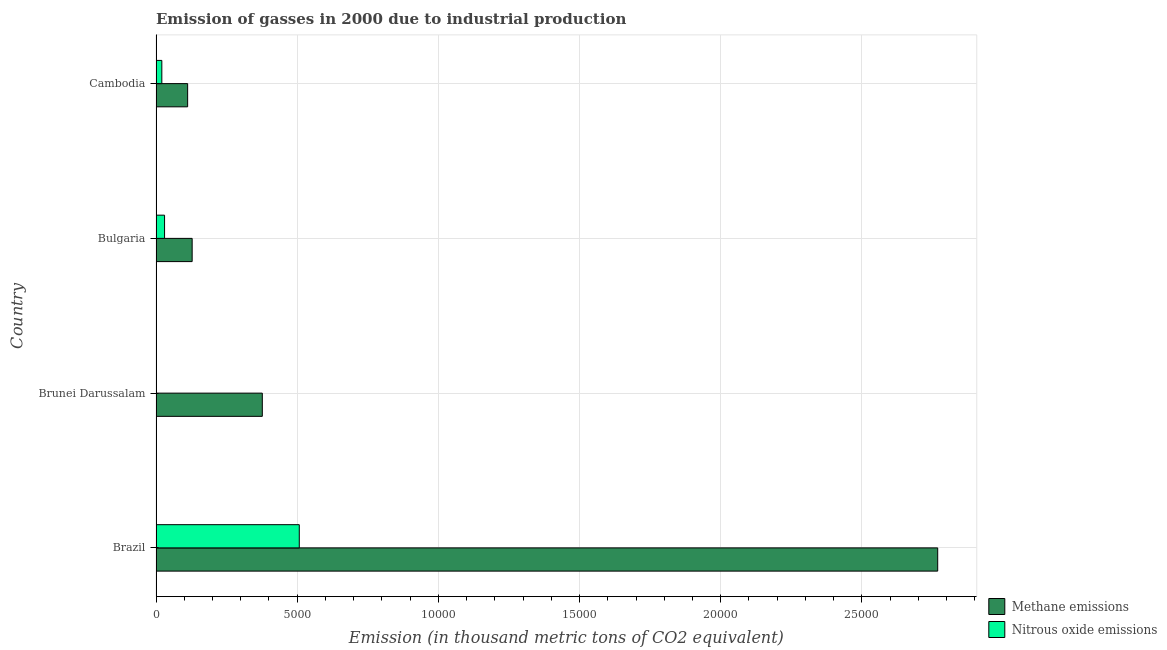How many different coloured bars are there?
Offer a very short reply. 2. Are the number of bars per tick equal to the number of legend labels?
Ensure brevity in your answer.  Yes. What is the label of the 3rd group of bars from the top?
Your answer should be very brief. Brunei Darussalam. What is the amount of nitrous oxide emissions in Brunei Darussalam?
Provide a succinct answer. 10.3. Across all countries, what is the maximum amount of methane emissions?
Keep it short and to the point. 2.77e+04. Across all countries, what is the minimum amount of methane emissions?
Your response must be concise. 1119.8. In which country was the amount of nitrous oxide emissions minimum?
Your answer should be very brief. Brunei Darussalam. What is the total amount of methane emissions in the graph?
Make the answer very short. 3.38e+04. What is the difference between the amount of nitrous oxide emissions in Brazil and that in Cambodia?
Provide a succinct answer. 4867.6. What is the difference between the amount of methane emissions in Brazil and the amount of nitrous oxide emissions in Cambodia?
Provide a succinct answer. 2.75e+04. What is the average amount of methane emissions per country?
Provide a succinct answer. 8461.75. What is the difference between the amount of nitrous oxide emissions and amount of methane emissions in Bulgaria?
Provide a short and direct response. -977.1. In how many countries, is the amount of methane emissions greater than 12000 thousand metric tons?
Your answer should be very brief. 1. What is the ratio of the amount of methane emissions in Bulgaria to that in Cambodia?
Offer a terse response. 1.14. What is the difference between the highest and the second highest amount of methane emissions?
Ensure brevity in your answer.  2.39e+04. What is the difference between the highest and the lowest amount of methane emissions?
Provide a succinct answer. 2.66e+04. What does the 2nd bar from the top in Brunei Darussalam represents?
Provide a succinct answer. Methane emissions. What does the 2nd bar from the bottom in Bulgaria represents?
Offer a very short reply. Nitrous oxide emissions. How many countries are there in the graph?
Give a very brief answer. 4. What is the difference between two consecutive major ticks on the X-axis?
Offer a terse response. 5000. Does the graph contain grids?
Your answer should be compact. Yes. Where does the legend appear in the graph?
Give a very brief answer. Bottom right. How many legend labels are there?
Ensure brevity in your answer.  2. How are the legend labels stacked?
Ensure brevity in your answer.  Vertical. What is the title of the graph?
Offer a terse response. Emission of gasses in 2000 due to industrial production. What is the label or title of the X-axis?
Provide a short and direct response. Emission (in thousand metric tons of CO2 equivalent). What is the Emission (in thousand metric tons of CO2 equivalent) in Methane emissions in Brazil?
Ensure brevity in your answer.  2.77e+04. What is the Emission (in thousand metric tons of CO2 equivalent) in Nitrous oxide emissions in Brazil?
Your answer should be very brief. 5073.4. What is the Emission (in thousand metric tons of CO2 equivalent) in Methane emissions in Brunei Darussalam?
Ensure brevity in your answer.  3764.1. What is the Emission (in thousand metric tons of CO2 equivalent) in Nitrous oxide emissions in Brunei Darussalam?
Ensure brevity in your answer.  10.3. What is the Emission (in thousand metric tons of CO2 equivalent) in Methane emissions in Bulgaria?
Offer a very short reply. 1279.7. What is the Emission (in thousand metric tons of CO2 equivalent) of Nitrous oxide emissions in Bulgaria?
Provide a succinct answer. 302.6. What is the Emission (in thousand metric tons of CO2 equivalent) of Methane emissions in Cambodia?
Your answer should be compact. 1119.8. What is the Emission (in thousand metric tons of CO2 equivalent) of Nitrous oxide emissions in Cambodia?
Your response must be concise. 205.8. Across all countries, what is the maximum Emission (in thousand metric tons of CO2 equivalent) of Methane emissions?
Give a very brief answer. 2.77e+04. Across all countries, what is the maximum Emission (in thousand metric tons of CO2 equivalent) in Nitrous oxide emissions?
Make the answer very short. 5073.4. Across all countries, what is the minimum Emission (in thousand metric tons of CO2 equivalent) in Methane emissions?
Provide a succinct answer. 1119.8. Across all countries, what is the minimum Emission (in thousand metric tons of CO2 equivalent) of Nitrous oxide emissions?
Provide a succinct answer. 10.3. What is the total Emission (in thousand metric tons of CO2 equivalent) of Methane emissions in the graph?
Your answer should be compact. 3.38e+04. What is the total Emission (in thousand metric tons of CO2 equivalent) in Nitrous oxide emissions in the graph?
Offer a very short reply. 5592.1. What is the difference between the Emission (in thousand metric tons of CO2 equivalent) in Methane emissions in Brazil and that in Brunei Darussalam?
Your answer should be very brief. 2.39e+04. What is the difference between the Emission (in thousand metric tons of CO2 equivalent) in Nitrous oxide emissions in Brazil and that in Brunei Darussalam?
Keep it short and to the point. 5063.1. What is the difference between the Emission (in thousand metric tons of CO2 equivalent) in Methane emissions in Brazil and that in Bulgaria?
Offer a very short reply. 2.64e+04. What is the difference between the Emission (in thousand metric tons of CO2 equivalent) in Nitrous oxide emissions in Brazil and that in Bulgaria?
Offer a terse response. 4770.8. What is the difference between the Emission (in thousand metric tons of CO2 equivalent) in Methane emissions in Brazil and that in Cambodia?
Your answer should be compact. 2.66e+04. What is the difference between the Emission (in thousand metric tons of CO2 equivalent) in Nitrous oxide emissions in Brazil and that in Cambodia?
Keep it short and to the point. 4867.6. What is the difference between the Emission (in thousand metric tons of CO2 equivalent) of Methane emissions in Brunei Darussalam and that in Bulgaria?
Make the answer very short. 2484.4. What is the difference between the Emission (in thousand metric tons of CO2 equivalent) of Nitrous oxide emissions in Brunei Darussalam and that in Bulgaria?
Your answer should be compact. -292.3. What is the difference between the Emission (in thousand metric tons of CO2 equivalent) in Methane emissions in Brunei Darussalam and that in Cambodia?
Your answer should be very brief. 2644.3. What is the difference between the Emission (in thousand metric tons of CO2 equivalent) in Nitrous oxide emissions in Brunei Darussalam and that in Cambodia?
Offer a very short reply. -195.5. What is the difference between the Emission (in thousand metric tons of CO2 equivalent) in Methane emissions in Bulgaria and that in Cambodia?
Provide a succinct answer. 159.9. What is the difference between the Emission (in thousand metric tons of CO2 equivalent) of Nitrous oxide emissions in Bulgaria and that in Cambodia?
Your answer should be compact. 96.8. What is the difference between the Emission (in thousand metric tons of CO2 equivalent) in Methane emissions in Brazil and the Emission (in thousand metric tons of CO2 equivalent) in Nitrous oxide emissions in Brunei Darussalam?
Ensure brevity in your answer.  2.77e+04. What is the difference between the Emission (in thousand metric tons of CO2 equivalent) in Methane emissions in Brazil and the Emission (in thousand metric tons of CO2 equivalent) in Nitrous oxide emissions in Bulgaria?
Offer a terse response. 2.74e+04. What is the difference between the Emission (in thousand metric tons of CO2 equivalent) in Methane emissions in Brazil and the Emission (in thousand metric tons of CO2 equivalent) in Nitrous oxide emissions in Cambodia?
Provide a succinct answer. 2.75e+04. What is the difference between the Emission (in thousand metric tons of CO2 equivalent) in Methane emissions in Brunei Darussalam and the Emission (in thousand metric tons of CO2 equivalent) in Nitrous oxide emissions in Bulgaria?
Offer a terse response. 3461.5. What is the difference between the Emission (in thousand metric tons of CO2 equivalent) of Methane emissions in Brunei Darussalam and the Emission (in thousand metric tons of CO2 equivalent) of Nitrous oxide emissions in Cambodia?
Provide a short and direct response. 3558.3. What is the difference between the Emission (in thousand metric tons of CO2 equivalent) of Methane emissions in Bulgaria and the Emission (in thousand metric tons of CO2 equivalent) of Nitrous oxide emissions in Cambodia?
Provide a succinct answer. 1073.9. What is the average Emission (in thousand metric tons of CO2 equivalent) of Methane emissions per country?
Make the answer very short. 8461.75. What is the average Emission (in thousand metric tons of CO2 equivalent) of Nitrous oxide emissions per country?
Keep it short and to the point. 1398.03. What is the difference between the Emission (in thousand metric tons of CO2 equivalent) of Methane emissions and Emission (in thousand metric tons of CO2 equivalent) of Nitrous oxide emissions in Brazil?
Your response must be concise. 2.26e+04. What is the difference between the Emission (in thousand metric tons of CO2 equivalent) of Methane emissions and Emission (in thousand metric tons of CO2 equivalent) of Nitrous oxide emissions in Brunei Darussalam?
Offer a very short reply. 3753.8. What is the difference between the Emission (in thousand metric tons of CO2 equivalent) in Methane emissions and Emission (in thousand metric tons of CO2 equivalent) in Nitrous oxide emissions in Bulgaria?
Offer a very short reply. 977.1. What is the difference between the Emission (in thousand metric tons of CO2 equivalent) in Methane emissions and Emission (in thousand metric tons of CO2 equivalent) in Nitrous oxide emissions in Cambodia?
Ensure brevity in your answer.  914. What is the ratio of the Emission (in thousand metric tons of CO2 equivalent) of Methane emissions in Brazil to that in Brunei Darussalam?
Your answer should be very brief. 7.35. What is the ratio of the Emission (in thousand metric tons of CO2 equivalent) in Nitrous oxide emissions in Brazil to that in Brunei Darussalam?
Make the answer very short. 492.56. What is the ratio of the Emission (in thousand metric tons of CO2 equivalent) in Methane emissions in Brazil to that in Bulgaria?
Your answer should be compact. 21.63. What is the ratio of the Emission (in thousand metric tons of CO2 equivalent) of Nitrous oxide emissions in Brazil to that in Bulgaria?
Keep it short and to the point. 16.77. What is the ratio of the Emission (in thousand metric tons of CO2 equivalent) in Methane emissions in Brazil to that in Cambodia?
Offer a very short reply. 24.72. What is the ratio of the Emission (in thousand metric tons of CO2 equivalent) of Nitrous oxide emissions in Brazil to that in Cambodia?
Offer a terse response. 24.65. What is the ratio of the Emission (in thousand metric tons of CO2 equivalent) of Methane emissions in Brunei Darussalam to that in Bulgaria?
Your response must be concise. 2.94. What is the ratio of the Emission (in thousand metric tons of CO2 equivalent) of Nitrous oxide emissions in Brunei Darussalam to that in Bulgaria?
Offer a terse response. 0.03. What is the ratio of the Emission (in thousand metric tons of CO2 equivalent) in Methane emissions in Brunei Darussalam to that in Cambodia?
Ensure brevity in your answer.  3.36. What is the ratio of the Emission (in thousand metric tons of CO2 equivalent) of Nitrous oxide emissions in Brunei Darussalam to that in Cambodia?
Offer a terse response. 0.05. What is the ratio of the Emission (in thousand metric tons of CO2 equivalent) in Methane emissions in Bulgaria to that in Cambodia?
Your response must be concise. 1.14. What is the ratio of the Emission (in thousand metric tons of CO2 equivalent) in Nitrous oxide emissions in Bulgaria to that in Cambodia?
Keep it short and to the point. 1.47. What is the difference between the highest and the second highest Emission (in thousand metric tons of CO2 equivalent) of Methane emissions?
Provide a short and direct response. 2.39e+04. What is the difference between the highest and the second highest Emission (in thousand metric tons of CO2 equivalent) in Nitrous oxide emissions?
Provide a succinct answer. 4770.8. What is the difference between the highest and the lowest Emission (in thousand metric tons of CO2 equivalent) in Methane emissions?
Offer a very short reply. 2.66e+04. What is the difference between the highest and the lowest Emission (in thousand metric tons of CO2 equivalent) in Nitrous oxide emissions?
Ensure brevity in your answer.  5063.1. 